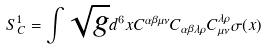<formula> <loc_0><loc_0><loc_500><loc_500>S _ { C } ^ { 1 } = \int \sqrt { g } d ^ { 6 } x C ^ { \alpha \beta \mu \nu } C _ { \alpha \beta \lambda \rho } C _ { \mu \nu } ^ { \lambda \rho } \sigma ( x )</formula> 